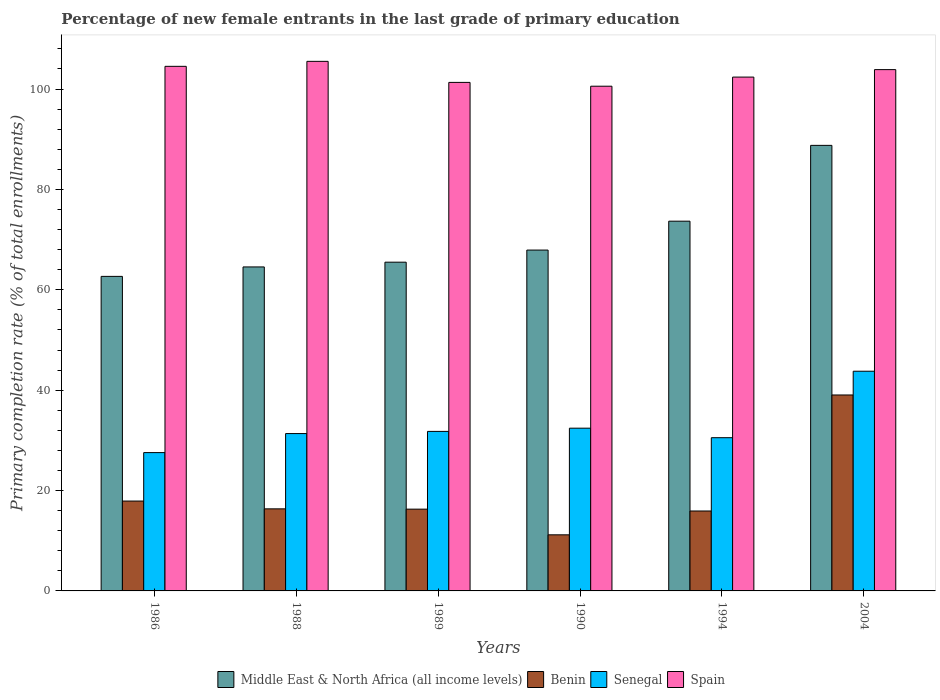How many bars are there on the 1st tick from the left?
Your answer should be compact. 4. How many bars are there on the 2nd tick from the right?
Offer a very short reply. 4. In how many cases, is the number of bars for a given year not equal to the number of legend labels?
Make the answer very short. 0. What is the percentage of new female entrants in Senegal in 1988?
Ensure brevity in your answer.  31.35. Across all years, what is the maximum percentage of new female entrants in Spain?
Offer a terse response. 105.51. Across all years, what is the minimum percentage of new female entrants in Senegal?
Offer a very short reply. 27.56. In which year was the percentage of new female entrants in Spain maximum?
Your answer should be compact. 1988. What is the total percentage of new female entrants in Benin in the graph?
Your response must be concise. 116.7. What is the difference between the percentage of new female entrants in Benin in 1986 and that in 1990?
Your response must be concise. 6.73. What is the difference between the percentage of new female entrants in Senegal in 1989 and the percentage of new female entrants in Spain in 1990?
Keep it short and to the point. -68.78. What is the average percentage of new female entrants in Benin per year?
Ensure brevity in your answer.  19.45. In the year 1986, what is the difference between the percentage of new female entrants in Senegal and percentage of new female entrants in Middle East & North Africa (all income levels)?
Provide a succinct answer. -35.11. In how many years, is the percentage of new female entrants in Spain greater than 12 %?
Offer a very short reply. 6. What is the ratio of the percentage of new female entrants in Spain in 1986 to that in 1994?
Ensure brevity in your answer.  1.02. Is the percentage of new female entrants in Middle East & North Africa (all income levels) in 1989 less than that in 1990?
Your answer should be compact. Yes. What is the difference between the highest and the second highest percentage of new female entrants in Senegal?
Make the answer very short. 11.35. What is the difference between the highest and the lowest percentage of new female entrants in Middle East & North Africa (all income levels)?
Give a very brief answer. 26.1. In how many years, is the percentage of new female entrants in Benin greater than the average percentage of new female entrants in Benin taken over all years?
Make the answer very short. 1. What does the 3rd bar from the left in 1988 represents?
Give a very brief answer. Senegal. What does the 3rd bar from the right in 1989 represents?
Ensure brevity in your answer.  Benin. Is it the case that in every year, the sum of the percentage of new female entrants in Benin and percentage of new female entrants in Spain is greater than the percentage of new female entrants in Senegal?
Your response must be concise. Yes. Are all the bars in the graph horizontal?
Ensure brevity in your answer.  No. What is the difference between two consecutive major ticks on the Y-axis?
Offer a terse response. 20. Does the graph contain grids?
Your answer should be compact. No. Where does the legend appear in the graph?
Your answer should be compact. Bottom center. What is the title of the graph?
Offer a terse response. Percentage of new female entrants in the last grade of primary education. Does "Tajikistan" appear as one of the legend labels in the graph?
Offer a terse response. No. What is the label or title of the X-axis?
Your answer should be very brief. Years. What is the label or title of the Y-axis?
Provide a short and direct response. Primary completion rate (% of total enrollments). What is the Primary completion rate (% of total enrollments) of Middle East & North Africa (all income levels) in 1986?
Your answer should be very brief. 62.67. What is the Primary completion rate (% of total enrollments) in Benin in 1986?
Your response must be concise. 17.91. What is the Primary completion rate (% of total enrollments) in Senegal in 1986?
Provide a short and direct response. 27.56. What is the Primary completion rate (% of total enrollments) of Spain in 1986?
Provide a short and direct response. 104.52. What is the Primary completion rate (% of total enrollments) of Middle East & North Africa (all income levels) in 1988?
Give a very brief answer. 64.55. What is the Primary completion rate (% of total enrollments) of Benin in 1988?
Provide a succinct answer. 16.35. What is the Primary completion rate (% of total enrollments) of Senegal in 1988?
Offer a terse response. 31.35. What is the Primary completion rate (% of total enrollments) in Spain in 1988?
Your answer should be compact. 105.51. What is the Primary completion rate (% of total enrollments) in Middle East & North Africa (all income levels) in 1989?
Ensure brevity in your answer.  65.5. What is the Primary completion rate (% of total enrollments) of Benin in 1989?
Provide a short and direct response. 16.29. What is the Primary completion rate (% of total enrollments) of Senegal in 1989?
Offer a terse response. 31.78. What is the Primary completion rate (% of total enrollments) of Spain in 1989?
Make the answer very short. 101.32. What is the Primary completion rate (% of total enrollments) of Middle East & North Africa (all income levels) in 1990?
Give a very brief answer. 67.91. What is the Primary completion rate (% of total enrollments) of Benin in 1990?
Offer a very short reply. 11.18. What is the Primary completion rate (% of total enrollments) of Senegal in 1990?
Offer a terse response. 32.43. What is the Primary completion rate (% of total enrollments) in Spain in 1990?
Ensure brevity in your answer.  100.56. What is the Primary completion rate (% of total enrollments) in Middle East & North Africa (all income levels) in 1994?
Ensure brevity in your answer.  73.67. What is the Primary completion rate (% of total enrollments) in Benin in 1994?
Make the answer very short. 15.92. What is the Primary completion rate (% of total enrollments) of Senegal in 1994?
Ensure brevity in your answer.  30.53. What is the Primary completion rate (% of total enrollments) of Spain in 1994?
Your response must be concise. 102.38. What is the Primary completion rate (% of total enrollments) of Middle East & North Africa (all income levels) in 2004?
Make the answer very short. 88.78. What is the Primary completion rate (% of total enrollments) of Benin in 2004?
Provide a succinct answer. 39.04. What is the Primary completion rate (% of total enrollments) in Senegal in 2004?
Your answer should be very brief. 43.77. What is the Primary completion rate (% of total enrollments) in Spain in 2004?
Provide a short and direct response. 103.87. Across all years, what is the maximum Primary completion rate (% of total enrollments) in Middle East & North Africa (all income levels)?
Ensure brevity in your answer.  88.78. Across all years, what is the maximum Primary completion rate (% of total enrollments) in Benin?
Offer a very short reply. 39.04. Across all years, what is the maximum Primary completion rate (% of total enrollments) in Senegal?
Make the answer very short. 43.77. Across all years, what is the maximum Primary completion rate (% of total enrollments) in Spain?
Your answer should be compact. 105.51. Across all years, what is the minimum Primary completion rate (% of total enrollments) of Middle East & North Africa (all income levels)?
Provide a succinct answer. 62.67. Across all years, what is the minimum Primary completion rate (% of total enrollments) in Benin?
Provide a short and direct response. 11.18. Across all years, what is the minimum Primary completion rate (% of total enrollments) of Senegal?
Provide a short and direct response. 27.56. Across all years, what is the minimum Primary completion rate (% of total enrollments) of Spain?
Your response must be concise. 100.56. What is the total Primary completion rate (% of total enrollments) of Middle East & North Africa (all income levels) in the graph?
Offer a very short reply. 423.08. What is the total Primary completion rate (% of total enrollments) of Benin in the graph?
Offer a terse response. 116.7. What is the total Primary completion rate (% of total enrollments) in Senegal in the graph?
Offer a very short reply. 197.42. What is the total Primary completion rate (% of total enrollments) of Spain in the graph?
Offer a very short reply. 618.16. What is the difference between the Primary completion rate (% of total enrollments) in Middle East & North Africa (all income levels) in 1986 and that in 1988?
Ensure brevity in your answer.  -1.88. What is the difference between the Primary completion rate (% of total enrollments) of Benin in 1986 and that in 1988?
Ensure brevity in your answer.  1.55. What is the difference between the Primary completion rate (% of total enrollments) in Senegal in 1986 and that in 1988?
Your response must be concise. -3.79. What is the difference between the Primary completion rate (% of total enrollments) in Spain in 1986 and that in 1988?
Your response must be concise. -0.99. What is the difference between the Primary completion rate (% of total enrollments) of Middle East & North Africa (all income levels) in 1986 and that in 1989?
Provide a short and direct response. -2.83. What is the difference between the Primary completion rate (% of total enrollments) of Benin in 1986 and that in 1989?
Your answer should be compact. 1.61. What is the difference between the Primary completion rate (% of total enrollments) of Senegal in 1986 and that in 1989?
Make the answer very short. -4.22. What is the difference between the Primary completion rate (% of total enrollments) of Spain in 1986 and that in 1989?
Provide a succinct answer. 3.2. What is the difference between the Primary completion rate (% of total enrollments) in Middle East & North Africa (all income levels) in 1986 and that in 1990?
Give a very brief answer. -5.24. What is the difference between the Primary completion rate (% of total enrollments) of Benin in 1986 and that in 1990?
Provide a succinct answer. 6.73. What is the difference between the Primary completion rate (% of total enrollments) in Senegal in 1986 and that in 1990?
Your answer should be compact. -4.87. What is the difference between the Primary completion rate (% of total enrollments) in Spain in 1986 and that in 1990?
Your response must be concise. 3.96. What is the difference between the Primary completion rate (% of total enrollments) of Middle East & North Africa (all income levels) in 1986 and that in 1994?
Provide a short and direct response. -11. What is the difference between the Primary completion rate (% of total enrollments) of Benin in 1986 and that in 1994?
Your answer should be very brief. 1.98. What is the difference between the Primary completion rate (% of total enrollments) in Senegal in 1986 and that in 1994?
Ensure brevity in your answer.  -2.97. What is the difference between the Primary completion rate (% of total enrollments) in Spain in 1986 and that in 1994?
Your answer should be compact. 2.14. What is the difference between the Primary completion rate (% of total enrollments) of Middle East & North Africa (all income levels) in 1986 and that in 2004?
Keep it short and to the point. -26.1. What is the difference between the Primary completion rate (% of total enrollments) in Benin in 1986 and that in 2004?
Your response must be concise. -21.14. What is the difference between the Primary completion rate (% of total enrollments) in Senegal in 1986 and that in 2004?
Your answer should be very brief. -16.21. What is the difference between the Primary completion rate (% of total enrollments) of Spain in 1986 and that in 2004?
Offer a very short reply. 0.65. What is the difference between the Primary completion rate (% of total enrollments) of Middle East & North Africa (all income levels) in 1988 and that in 1989?
Provide a short and direct response. -0.95. What is the difference between the Primary completion rate (% of total enrollments) in Benin in 1988 and that in 1989?
Your response must be concise. 0.06. What is the difference between the Primary completion rate (% of total enrollments) of Senegal in 1988 and that in 1989?
Provide a succinct answer. -0.43. What is the difference between the Primary completion rate (% of total enrollments) of Spain in 1988 and that in 1989?
Provide a succinct answer. 4.19. What is the difference between the Primary completion rate (% of total enrollments) of Middle East & North Africa (all income levels) in 1988 and that in 1990?
Provide a succinct answer. -3.36. What is the difference between the Primary completion rate (% of total enrollments) in Benin in 1988 and that in 1990?
Offer a terse response. 5.18. What is the difference between the Primary completion rate (% of total enrollments) in Senegal in 1988 and that in 1990?
Make the answer very short. -1.08. What is the difference between the Primary completion rate (% of total enrollments) in Spain in 1988 and that in 1990?
Make the answer very short. 4.95. What is the difference between the Primary completion rate (% of total enrollments) in Middle East & North Africa (all income levels) in 1988 and that in 1994?
Offer a terse response. -9.12. What is the difference between the Primary completion rate (% of total enrollments) in Benin in 1988 and that in 1994?
Offer a very short reply. 0.43. What is the difference between the Primary completion rate (% of total enrollments) in Senegal in 1988 and that in 1994?
Offer a terse response. 0.82. What is the difference between the Primary completion rate (% of total enrollments) in Spain in 1988 and that in 1994?
Ensure brevity in your answer.  3.14. What is the difference between the Primary completion rate (% of total enrollments) in Middle East & North Africa (all income levels) in 1988 and that in 2004?
Your response must be concise. -24.22. What is the difference between the Primary completion rate (% of total enrollments) of Benin in 1988 and that in 2004?
Offer a terse response. -22.69. What is the difference between the Primary completion rate (% of total enrollments) in Senegal in 1988 and that in 2004?
Ensure brevity in your answer.  -12.42. What is the difference between the Primary completion rate (% of total enrollments) in Spain in 1988 and that in 2004?
Your answer should be compact. 1.65. What is the difference between the Primary completion rate (% of total enrollments) in Middle East & North Africa (all income levels) in 1989 and that in 1990?
Keep it short and to the point. -2.41. What is the difference between the Primary completion rate (% of total enrollments) of Benin in 1989 and that in 1990?
Ensure brevity in your answer.  5.12. What is the difference between the Primary completion rate (% of total enrollments) in Senegal in 1989 and that in 1990?
Offer a terse response. -0.64. What is the difference between the Primary completion rate (% of total enrollments) in Spain in 1989 and that in 1990?
Make the answer very short. 0.76. What is the difference between the Primary completion rate (% of total enrollments) in Middle East & North Africa (all income levels) in 1989 and that in 1994?
Give a very brief answer. -8.17. What is the difference between the Primary completion rate (% of total enrollments) in Benin in 1989 and that in 1994?
Make the answer very short. 0.37. What is the difference between the Primary completion rate (% of total enrollments) in Senegal in 1989 and that in 1994?
Ensure brevity in your answer.  1.25. What is the difference between the Primary completion rate (% of total enrollments) of Spain in 1989 and that in 1994?
Provide a succinct answer. -1.06. What is the difference between the Primary completion rate (% of total enrollments) of Middle East & North Africa (all income levels) in 1989 and that in 2004?
Provide a succinct answer. -23.27. What is the difference between the Primary completion rate (% of total enrollments) of Benin in 1989 and that in 2004?
Ensure brevity in your answer.  -22.75. What is the difference between the Primary completion rate (% of total enrollments) in Senegal in 1989 and that in 2004?
Offer a very short reply. -11.99. What is the difference between the Primary completion rate (% of total enrollments) in Spain in 1989 and that in 2004?
Your answer should be compact. -2.55. What is the difference between the Primary completion rate (% of total enrollments) in Middle East & North Africa (all income levels) in 1990 and that in 1994?
Provide a succinct answer. -5.75. What is the difference between the Primary completion rate (% of total enrollments) in Benin in 1990 and that in 1994?
Your response must be concise. -4.75. What is the difference between the Primary completion rate (% of total enrollments) in Senegal in 1990 and that in 1994?
Your answer should be compact. 1.9. What is the difference between the Primary completion rate (% of total enrollments) in Spain in 1990 and that in 1994?
Provide a short and direct response. -1.82. What is the difference between the Primary completion rate (% of total enrollments) in Middle East & North Africa (all income levels) in 1990 and that in 2004?
Provide a succinct answer. -20.86. What is the difference between the Primary completion rate (% of total enrollments) in Benin in 1990 and that in 2004?
Offer a terse response. -27.87. What is the difference between the Primary completion rate (% of total enrollments) of Senegal in 1990 and that in 2004?
Give a very brief answer. -11.35. What is the difference between the Primary completion rate (% of total enrollments) in Spain in 1990 and that in 2004?
Provide a short and direct response. -3.31. What is the difference between the Primary completion rate (% of total enrollments) of Middle East & North Africa (all income levels) in 1994 and that in 2004?
Offer a very short reply. -15.11. What is the difference between the Primary completion rate (% of total enrollments) of Benin in 1994 and that in 2004?
Provide a short and direct response. -23.12. What is the difference between the Primary completion rate (% of total enrollments) in Senegal in 1994 and that in 2004?
Your answer should be compact. -13.24. What is the difference between the Primary completion rate (% of total enrollments) in Spain in 1994 and that in 2004?
Keep it short and to the point. -1.49. What is the difference between the Primary completion rate (% of total enrollments) of Middle East & North Africa (all income levels) in 1986 and the Primary completion rate (% of total enrollments) of Benin in 1988?
Offer a very short reply. 46.32. What is the difference between the Primary completion rate (% of total enrollments) of Middle East & North Africa (all income levels) in 1986 and the Primary completion rate (% of total enrollments) of Senegal in 1988?
Give a very brief answer. 31.32. What is the difference between the Primary completion rate (% of total enrollments) of Middle East & North Africa (all income levels) in 1986 and the Primary completion rate (% of total enrollments) of Spain in 1988?
Give a very brief answer. -42.84. What is the difference between the Primary completion rate (% of total enrollments) of Benin in 1986 and the Primary completion rate (% of total enrollments) of Senegal in 1988?
Offer a terse response. -13.44. What is the difference between the Primary completion rate (% of total enrollments) in Benin in 1986 and the Primary completion rate (% of total enrollments) in Spain in 1988?
Keep it short and to the point. -87.61. What is the difference between the Primary completion rate (% of total enrollments) in Senegal in 1986 and the Primary completion rate (% of total enrollments) in Spain in 1988?
Make the answer very short. -77.95. What is the difference between the Primary completion rate (% of total enrollments) in Middle East & North Africa (all income levels) in 1986 and the Primary completion rate (% of total enrollments) in Benin in 1989?
Offer a terse response. 46.38. What is the difference between the Primary completion rate (% of total enrollments) in Middle East & North Africa (all income levels) in 1986 and the Primary completion rate (% of total enrollments) in Senegal in 1989?
Your response must be concise. 30.89. What is the difference between the Primary completion rate (% of total enrollments) in Middle East & North Africa (all income levels) in 1986 and the Primary completion rate (% of total enrollments) in Spain in 1989?
Make the answer very short. -38.65. What is the difference between the Primary completion rate (% of total enrollments) in Benin in 1986 and the Primary completion rate (% of total enrollments) in Senegal in 1989?
Offer a very short reply. -13.88. What is the difference between the Primary completion rate (% of total enrollments) in Benin in 1986 and the Primary completion rate (% of total enrollments) in Spain in 1989?
Keep it short and to the point. -83.41. What is the difference between the Primary completion rate (% of total enrollments) in Senegal in 1986 and the Primary completion rate (% of total enrollments) in Spain in 1989?
Give a very brief answer. -73.76. What is the difference between the Primary completion rate (% of total enrollments) in Middle East & North Africa (all income levels) in 1986 and the Primary completion rate (% of total enrollments) in Benin in 1990?
Your response must be concise. 51.49. What is the difference between the Primary completion rate (% of total enrollments) of Middle East & North Africa (all income levels) in 1986 and the Primary completion rate (% of total enrollments) of Senegal in 1990?
Give a very brief answer. 30.24. What is the difference between the Primary completion rate (% of total enrollments) of Middle East & North Africa (all income levels) in 1986 and the Primary completion rate (% of total enrollments) of Spain in 1990?
Offer a very short reply. -37.89. What is the difference between the Primary completion rate (% of total enrollments) in Benin in 1986 and the Primary completion rate (% of total enrollments) in Senegal in 1990?
Offer a very short reply. -14.52. What is the difference between the Primary completion rate (% of total enrollments) of Benin in 1986 and the Primary completion rate (% of total enrollments) of Spain in 1990?
Provide a short and direct response. -82.66. What is the difference between the Primary completion rate (% of total enrollments) in Senegal in 1986 and the Primary completion rate (% of total enrollments) in Spain in 1990?
Keep it short and to the point. -73. What is the difference between the Primary completion rate (% of total enrollments) of Middle East & North Africa (all income levels) in 1986 and the Primary completion rate (% of total enrollments) of Benin in 1994?
Provide a short and direct response. 46.75. What is the difference between the Primary completion rate (% of total enrollments) in Middle East & North Africa (all income levels) in 1986 and the Primary completion rate (% of total enrollments) in Senegal in 1994?
Ensure brevity in your answer.  32.14. What is the difference between the Primary completion rate (% of total enrollments) in Middle East & North Africa (all income levels) in 1986 and the Primary completion rate (% of total enrollments) in Spain in 1994?
Offer a very short reply. -39.71. What is the difference between the Primary completion rate (% of total enrollments) of Benin in 1986 and the Primary completion rate (% of total enrollments) of Senegal in 1994?
Offer a very short reply. -12.62. What is the difference between the Primary completion rate (% of total enrollments) in Benin in 1986 and the Primary completion rate (% of total enrollments) in Spain in 1994?
Your response must be concise. -84.47. What is the difference between the Primary completion rate (% of total enrollments) in Senegal in 1986 and the Primary completion rate (% of total enrollments) in Spain in 1994?
Your response must be concise. -74.82. What is the difference between the Primary completion rate (% of total enrollments) of Middle East & North Africa (all income levels) in 1986 and the Primary completion rate (% of total enrollments) of Benin in 2004?
Give a very brief answer. 23.63. What is the difference between the Primary completion rate (% of total enrollments) in Middle East & North Africa (all income levels) in 1986 and the Primary completion rate (% of total enrollments) in Senegal in 2004?
Your answer should be very brief. 18.9. What is the difference between the Primary completion rate (% of total enrollments) of Middle East & North Africa (all income levels) in 1986 and the Primary completion rate (% of total enrollments) of Spain in 2004?
Your answer should be compact. -41.2. What is the difference between the Primary completion rate (% of total enrollments) in Benin in 1986 and the Primary completion rate (% of total enrollments) in Senegal in 2004?
Your answer should be compact. -25.87. What is the difference between the Primary completion rate (% of total enrollments) in Benin in 1986 and the Primary completion rate (% of total enrollments) in Spain in 2004?
Provide a short and direct response. -85.96. What is the difference between the Primary completion rate (% of total enrollments) in Senegal in 1986 and the Primary completion rate (% of total enrollments) in Spain in 2004?
Ensure brevity in your answer.  -76.31. What is the difference between the Primary completion rate (% of total enrollments) in Middle East & North Africa (all income levels) in 1988 and the Primary completion rate (% of total enrollments) in Benin in 1989?
Give a very brief answer. 48.26. What is the difference between the Primary completion rate (% of total enrollments) in Middle East & North Africa (all income levels) in 1988 and the Primary completion rate (% of total enrollments) in Senegal in 1989?
Your response must be concise. 32.77. What is the difference between the Primary completion rate (% of total enrollments) of Middle East & North Africa (all income levels) in 1988 and the Primary completion rate (% of total enrollments) of Spain in 1989?
Give a very brief answer. -36.77. What is the difference between the Primary completion rate (% of total enrollments) in Benin in 1988 and the Primary completion rate (% of total enrollments) in Senegal in 1989?
Provide a short and direct response. -15.43. What is the difference between the Primary completion rate (% of total enrollments) in Benin in 1988 and the Primary completion rate (% of total enrollments) in Spain in 1989?
Offer a terse response. -84.97. What is the difference between the Primary completion rate (% of total enrollments) in Senegal in 1988 and the Primary completion rate (% of total enrollments) in Spain in 1989?
Make the answer very short. -69.97. What is the difference between the Primary completion rate (% of total enrollments) of Middle East & North Africa (all income levels) in 1988 and the Primary completion rate (% of total enrollments) of Benin in 1990?
Make the answer very short. 53.38. What is the difference between the Primary completion rate (% of total enrollments) of Middle East & North Africa (all income levels) in 1988 and the Primary completion rate (% of total enrollments) of Senegal in 1990?
Ensure brevity in your answer.  32.13. What is the difference between the Primary completion rate (% of total enrollments) of Middle East & North Africa (all income levels) in 1988 and the Primary completion rate (% of total enrollments) of Spain in 1990?
Keep it short and to the point. -36.01. What is the difference between the Primary completion rate (% of total enrollments) in Benin in 1988 and the Primary completion rate (% of total enrollments) in Senegal in 1990?
Your response must be concise. -16.07. What is the difference between the Primary completion rate (% of total enrollments) of Benin in 1988 and the Primary completion rate (% of total enrollments) of Spain in 1990?
Offer a terse response. -84.21. What is the difference between the Primary completion rate (% of total enrollments) of Senegal in 1988 and the Primary completion rate (% of total enrollments) of Spain in 1990?
Your answer should be very brief. -69.21. What is the difference between the Primary completion rate (% of total enrollments) of Middle East & North Africa (all income levels) in 1988 and the Primary completion rate (% of total enrollments) of Benin in 1994?
Provide a short and direct response. 48.63. What is the difference between the Primary completion rate (% of total enrollments) of Middle East & North Africa (all income levels) in 1988 and the Primary completion rate (% of total enrollments) of Senegal in 1994?
Offer a terse response. 34.02. What is the difference between the Primary completion rate (% of total enrollments) in Middle East & North Africa (all income levels) in 1988 and the Primary completion rate (% of total enrollments) in Spain in 1994?
Keep it short and to the point. -37.83. What is the difference between the Primary completion rate (% of total enrollments) in Benin in 1988 and the Primary completion rate (% of total enrollments) in Senegal in 1994?
Keep it short and to the point. -14.18. What is the difference between the Primary completion rate (% of total enrollments) of Benin in 1988 and the Primary completion rate (% of total enrollments) of Spain in 1994?
Make the answer very short. -86.02. What is the difference between the Primary completion rate (% of total enrollments) in Senegal in 1988 and the Primary completion rate (% of total enrollments) in Spain in 1994?
Your answer should be very brief. -71.03. What is the difference between the Primary completion rate (% of total enrollments) of Middle East & North Africa (all income levels) in 1988 and the Primary completion rate (% of total enrollments) of Benin in 2004?
Your answer should be very brief. 25.51. What is the difference between the Primary completion rate (% of total enrollments) of Middle East & North Africa (all income levels) in 1988 and the Primary completion rate (% of total enrollments) of Senegal in 2004?
Offer a very short reply. 20.78. What is the difference between the Primary completion rate (% of total enrollments) in Middle East & North Africa (all income levels) in 1988 and the Primary completion rate (% of total enrollments) in Spain in 2004?
Your response must be concise. -39.32. What is the difference between the Primary completion rate (% of total enrollments) in Benin in 1988 and the Primary completion rate (% of total enrollments) in Senegal in 2004?
Ensure brevity in your answer.  -27.42. What is the difference between the Primary completion rate (% of total enrollments) of Benin in 1988 and the Primary completion rate (% of total enrollments) of Spain in 2004?
Your answer should be very brief. -87.51. What is the difference between the Primary completion rate (% of total enrollments) in Senegal in 1988 and the Primary completion rate (% of total enrollments) in Spain in 2004?
Ensure brevity in your answer.  -72.52. What is the difference between the Primary completion rate (% of total enrollments) in Middle East & North Africa (all income levels) in 1989 and the Primary completion rate (% of total enrollments) in Benin in 1990?
Make the answer very short. 54.32. What is the difference between the Primary completion rate (% of total enrollments) of Middle East & North Africa (all income levels) in 1989 and the Primary completion rate (% of total enrollments) of Senegal in 1990?
Your answer should be compact. 33.07. What is the difference between the Primary completion rate (% of total enrollments) of Middle East & North Africa (all income levels) in 1989 and the Primary completion rate (% of total enrollments) of Spain in 1990?
Provide a short and direct response. -35.06. What is the difference between the Primary completion rate (% of total enrollments) in Benin in 1989 and the Primary completion rate (% of total enrollments) in Senegal in 1990?
Provide a short and direct response. -16.13. What is the difference between the Primary completion rate (% of total enrollments) in Benin in 1989 and the Primary completion rate (% of total enrollments) in Spain in 1990?
Provide a succinct answer. -84.27. What is the difference between the Primary completion rate (% of total enrollments) of Senegal in 1989 and the Primary completion rate (% of total enrollments) of Spain in 1990?
Provide a succinct answer. -68.78. What is the difference between the Primary completion rate (% of total enrollments) of Middle East & North Africa (all income levels) in 1989 and the Primary completion rate (% of total enrollments) of Benin in 1994?
Your response must be concise. 49.58. What is the difference between the Primary completion rate (% of total enrollments) of Middle East & North Africa (all income levels) in 1989 and the Primary completion rate (% of total enrollments) of Senegal in 1994?
Ensure brevity in your answer.  34.97. What is the difference between the Primary completion rate (% of total enrollments) of Middle East & North Africa (all income levels) in 1989 and the Primary completion rate (% of total enrollments) of Spain in 1994?
Your response must be concise. -36.88. What is the difference between the Primary completion rate (% of total enrollments) of Benin in 1989 and the Primary completion rate (% of total enrollments) of Senegal in 1994?
Provide a succinct answer. -14.24. What is the difference between the Primary completion rate (% of total enrollments) in Benin in 1989 and the Primary completion rate (% of total enrollments) in Spain in 1994?
Provide a short and direct response. -86.08. What is the difference between the Primary completion rate (% of total enrollments) in Senegal in 1989 and the Primary completion rate (% of total enrollments) in Spain in 1994?
Your response must be concise. -70.59. What is the difference between the Primary completion rate (% of total enrollments) of Middle East & North Africa (all income levels) in 1989 and the Primary completion rate (% of total enrollments) of Benin in 2004?
Your answer should be very brief. 26.46. What is the difference between the Primary completion rate (% of total enrollments) of Middle East & North Africa (all income levels) in 1989 and the Primary completion rate (% of total enrollments) of Senegal in 2004?
Your answer should be compact. 21.73. What is the difference between the Primary completion rate (% of total enrollments) of Middle East & North Africa (all income levels) in 1989 and the Primary completion rate (% of total enrollments) of Spain in 2004?
Offer a very short reply. -38.37. What is the difference between the Primary completion rate (% of total enrollments) in Benin in 1989 and the Primary completion rate (% of total enrollments) in Senegal in 2004?
Give a very brief answer. -27.48. What is the difference between the Primary completion rate (% of total enrollments) of Benin in 1989 and the Primary completion rate (% of total enrollments) of Spain in 2004?
Offer a terse response. -87.57. What is the difference between the Primary completion rate (% of total enrollments) of Senegal in 1989 and the Primary completion rate (% of total enrollments) of Spain in 2004?
Offer a very short reply. -72.08. What is the difference between the Primary completion rate (% of total enrollments) of Middle East & North Africa (all income levels) in 1990 and the Primary completion rate (% of total enrollments) of Benin in 1994?
Give a very brief answer. 51.99. What is the difference between the Primary completion rate (% of total enrollments) in Middle East & North Africa (all income levels) in 1990 and the Primary completion rate (% of total enrollments) in Senegal in 1994?
Your response must be concise. 37.38. What is the difference between the Primary completion rate (% of total enrollments) of Middle East & North Africa (all income levels) in 1990 and the Primary completion rate (% of total enrollments) of Spain in 1994?
Provide a succinct answer. -34.46. What is the difference between the Primary completion rate (% of total enrollments) in Benin in 1990 and the Primary completion rate (% of total enrollments) in Senegal in 1994?
Your response must be concise. -19.35. What is the difference between the Primary completion rate (% of total enrollments) of Benin in 1990 and the Primary completion rate (% of total enrollments) of Spain in 1994?
Offer a terse response. -91.2. What is the difference between the Primary completion rate (% of total enrollments) of Senegal in 1990 and the Primary completion rate (% of total enrollments) of Spain in 1994?
Ensure brevity in your answer.  -69.95. What is the difference between the Primary completion rate (% of total enrollments) in Middle East & North Africa (all income levels) in 1990 and the Primary completion rate (% of total enrollments) in Benin in 2004?
Provide a short and direct response. 28.87. What is the difference between the Primary completion rate (% of total enrollments) in Middle East & North Africa (all income levels) in 1990 and the Primary completion rate (% of total enrollments) in Senegal in 2004?
Give a very brief answer. 24.14. What is the difference between the Primary completion rate (% of total enrollments) of Middle East & North Africa (all income levels) in 1990 and the Primary completion rate (% of total enrollments) of Spain in 2004?
Make the answer very short. -35.95. What is the difference between the Primary completion rate (% of total enrollments) in Benin in 1990 and the Primary completion rate (% of total enrollments) in Senegal in 2004?
Your answer should be compact. -32.6. What is the difference between the Primary completion rate (% of total enrollments) of Benin in 1990 and the Primary completion rate (% of total enrollments) of Spain in 2004?
Your answer should be compact. -92.69. What is the difference between the Primary completion rate (% of total enrollments) of Senegal in 1990 and the Primary completion rate (% of total enrollments) of Spain in 2004?
Ensure brevity in your answer.  -71.44. What is the difference between the Primary completion rate (% of total enrollments) in Middle East & North Africa (all income levels) in 1994 and the Primary completion rate (% of total enrollments) in Benin in 2004?
Offer a very short reply. 34.62. What is the difference between the Primary completion rate (% of total enrollments) in Middle East & North Africa (all income levels) in 1994 and the Primary completion rate (% of total enrollments) in Senegal in 2004?
Keep it short and to the point. 29.9. What is the difference between the Primary completion rate (% of total enrollments) of Middle East & North Africa (all income levels) in 1994 and the Primary completion rate (% of total enrollments) of Spain in 2004?
Your answer should be compact. -30.2. What is the difference between the Primary completion rate (% of total enrollments) of Benin in 1994 and the Primary completion rate (% of total enrollments) of Senegal in 2004?
Provide a succinct answer. -27.85. What is the difference between the Primary completion rate (% of total enrollments) in Benin in 1994 and the Primary completion rate (% of total enrollments) in Spain in 2004?
Offer a terse response. -87.94. What is the difference between the Primary completion rate (% of total enrollments) of Senegal in 1994 and the Primary completion rate (% of total enrollments) of Spain in 2004?
Ensure brevity in your answer.  -73.34. What is the average Primary completion rate (% of total enrollments) in Middle East & North Africa (all income levels) per year?
Offer a very short reply. 70.51. What is the average Primary completion rate (% of total enrollments) of Benin per year?
Your answer should be very brief. 19.45. What is the average Primary completion rate (% of total enrollments) of Senegal per year?
Your answer should be compact. 32.9. What is the average Primary completion rate (% of total enrollments) of Spain per year?
Keep it short and to the point. 103.03. In the year 1986, what is the difference between the Primary completion rate (% of total enrollments) of Middle East & North Africa (all income levels) and Primary completion rate (% of total enrollments) of Benin?
Offer a terse response. 44.76. In the year 1986, what is the difference between the Primary completion rate (% of total enrollments) of Middle East & North Africa (all income levels) and Primary completion rate (% of total enrollments) of Senegal?
Offer a very short reply. 35.11. In the year 1986, what is the difference between the Primary completion rate (% of total enrollments) in Middle East & North Africa (all income levels) and Primary completion rate (% of total enrollments) in Spain?
Give a very brief answer. -41.85. In the year 1986, what is the difference between the Primary completion rate (% of total enrollments) in Benin and Primary completion rate (% of total enrollments) in Senegal?
Give a very brief answer. -9.65. In the year 1986, what is the difference between the Primary completion rate (% of total enrollments) of Benin and Primary completion rate (% of total enrollments) of Spain?
Keep it short and to the point. -86.62. In the year 1986, what is the difference between the Primary completion rate (% of total enrollments) of Senegal and Primary completion rate (% of total enrollments) of Spain?
Keep it short and to the point. -76.96. In the year 1988, what is the difference between the Primary completion rate (% of total enrollments) of Middle East & North Africa (all income levels) and Primary completion rate (% of total enrollments) of Benin?
Offer a very short reply. 48.2. In the year 1988, what is the difference between the Primary completion rate (% of total enrollments) in Middle East & North Africa (all income levels) and Primary completion rate (% of total enrollments) in Senegal?
Provide a succinct answer. 33.2. In the year 1988, what is the difference between the Primary completion rate (% of total enrollments) of Middle East & North Africa (all income levels) and Primary completion rate (% of total enrollments) of Spain?
Your answer should be compact. -40.96. In the year 1988, what is the difference between the Primary completion rate (% of total enrollments) of Benin and Primary completion rate (% of total enrollments) of Senegal?
Keep it short and to the point. -15. In the year 1988, what is the difference between the Primary completion rate (% of total enrollments) in Benin and Primary completion rate (% of total enrollments) in Spain?
Offer a very short reply. -89.16. In the year 1988, what is the difference between the Primary completion rate (% of total enrollments) in Senegal and Primary completion rate (% of total enrollments) in Spain?
Keep it short and to the point. -74.16. In the year 1989, what is the difference between the Primary completion rate (% of total enrollments) of Middle East & North Africa (all income levels) and Primary completion rate (% of total enrollments) of Benin?
Your response must be concise. 49.21. In the year 1989, what is the difference between the Primary completion rate (% of total enrollments) of Middle East & North Africa (all income levels) and Primary completion rate (% of total enrollments) of Senegal?
Provide a short and direct response. 33.72. In the year 1989, what is the difference between the Primary completion rate (% of total enrollments) of Middle East & North Africa (all income levels) and Primary completion rate (% of total enrollments) of Spain?
Offer a very short reply. -35.82. In the year 1989, what is the difference between the Primary completion rate (% of total enrollments) in Benin and Primary completion rate (% of total enrollments) in Senegal?
Provide a short and direct response. -15.49. In the year 1989, what is the difference between the Primary completion rate (% of total enrollments) of Benin and Primary completion rate (% of total enrollments) of Spain?
Offer a terse response. -85.02. In the year 1989, what is the difference between the Primary completion rate (% of total enrollments) in Senegal and Primary completion rate (% of total enrollments) in Spain?
Provide a short and direct response. -69.54. In the year 1990, what is the difference between the Primary completion rate (% of total enrollments) of Middle East & North Africa (all income levels) and Primary completion rate (% of total enrollments) of Benin?
Give a very brief answer. 56.74. In the year 1990, what is the difference between the Primary completion rate (% of total enrollments) of Middle East & North Africa (all income levels) and Primary completion rate (% of total enrollments) of Senegal?
Give a very brief answer. 35.49. In the year 1990, what is the difference between the Primary completion rate (% of total enrollments) of Middle East & North Africa (all income levels) and Primary completion rate (% of total enrollments) of Spain?
Keep it short and to the point. -32.65. In the year 1990, what is the difference between the Primary completion rate (% of total enrollments) in Benin and Primary completion rate (% of total enrollments) in Senegal?
Your answer should be very brief. -21.25. In the year 1990, what is the difference between the Primary completion rate (% of total enrollments) of Benin and Primary completion rate (% of total enrollments) of Spain?
Provide a succinct answer. -89.38. In the year 1990, what is the difference between the Primary completion rate (% of total enrollments) in Senegal and Primary completion rate (% of total enrollments) in Spain?
Provide a short and direct response. -68.13. In the year 1994, what is the difference between the Primary completion rate (% of total enrollments) in Middle East & North Africa (all income levels) and Primary completion rate (% of total enrollments) in Benin?
Make the answer very short. 57.74. In the year 1994, what is the difference between the Primary completion rate (% of total enrollments) in Middle East & North Africa (all income levels) and Primary completion rate (% of total enrollments) in Senegal?
Give a very brief answer. 43.14. In the year 1994, what is the difference between the Primary completion rate (% of total enrollments) in Middle East & North Africa (all income levels) and Primary completion rate (% of total enrollments) in Spain?
Give a very brief answer. -28.71. In the year 1994, what is the difference between the Primary completion rate (% of total enrollments) of Benin and Primary completion rate (% of total enrollments) of Senegal?
Provide a short and direct response. -14.61. In the year 1994, what is the difference between the Primary completion rate (% of total enrollments) in Benin and Primary completion rate (% of total enrollments) in Spain?
Ensure brevity in your answer.  -86.45. In the year 1994, what is the difference between the Primary completion rate (% of total enrollments) in Senegal and Primary completion rate (% of total enrollments) in Spain?
Give a very brief answer. -71.85. In the year 2004, what is the difference between the Primary completion rate (% of total enrollments) in Middle East & North Africa (all income levels) and Primary completion rate (% of total enrollments) in Benin?
Your answer should be very brief. 49.73. In the year 2004, what is the difference between the Primary completion rate (% of total enrollments) of Middle East & North Africa (all income levels) and Primary completion rate (% of total enrollments) of Senegal?
Keep it short and to the point. 45. In the year 2004, what is the difference between the Primary completion rate (% of total enrollments) in Middle East & North Africa (all income levels) and Primary completion rate (% of total enrollments) in Spain?
Your answer should be compact. -15.09. In the year 2004, what is the difference between the Primary completion rate (% of total enrollments) in Benin and Primary completion rate (% of total enrollments) in Senegal?
Offer a very short reply. -4.73. In the year 2004, what is the difference between the Primary completion rate (% of total enrollments) of Benin and Primary completion rate (% of total enrollments) of Spain?
Make the answer very short. -64.83. In the year 2004, what is the difference between the Primary completion rate (% of total enrollments) in Senegal and Primary completion rate (% of total enrollments) in Spain?
Your answer should be very brief. -60.1. What is the ratio of the Primary completion rate (% of total enrollments) in Middle East & North Africa (all income levels) in 1986 to that in 1988?
Your answer should be compact. 0.97. What is the ratio of the Primary completion rate (% of total enrollments) of Benin in 1986 to that in 1988?
Provide a succinct answer. 1.09. What is the ratio of the Primary completion rate (% of total enrollments) of Senegal in 1986 to that in 1988?
Offer a very short reply. 0.88. What is the ratio of the Primary completion rate (% of total enrollments) in Spain in 1986 to that in 1988?
Provide a succinct answer. 0.99. What is the ratio of the Primary completion rate (% of total enrollments) in Middle East & North Africa (all income levels) in 1986 to that in 1989?
Keep it short and to the point. 0.96. What is the ratio of the Primary completion rate (% of total enrollments) of Benin in 1986 to that in 1989?
Your answer should be compact. 1.1. What is the ratio of the Primary completion rate (% of total enrollments) in Senegal in 1986 to that in 1989?
Provide a short and direct response. 0.87. What is the ratio of the Primary completion rate (% of total enrollments) in Spain in 1986 to that in 1989?
Provide a succinct answer. 1.03. What is the ratio of the Primary completion rate (% of total enrollments) of Middle East & North Africa (all income levels) in 1986 to that in 1990?
Keep it short and to the point. 0.92. What is the ratio of the Primary completion rate (% of total enrollments) in Benin in 1986 to that in 1990?
Provide a succinct answer. 1.6. What is the ratio of the Primary completion rate (% of total enrollments) of Senegal in 1986 to that in 1990?
Give a very brief answer. 0.85. What is the ratio of the Primary completion rate (% of total enrollments) in Spain in 1986 to that in 1990?
Provide a succinct answer. 1.04. What is the ratio of the Primary completion rate (% of total enrollments) in Middle East & North Africa (all income levels) in 1986 to that in 1994?
Your answer should be very brief. 0.85. What is the ratio of the Primary completion rate (% of total enrollments) in Benin in 1986 to that in 1994?
Make the answer very short. 1.12. What is the ratio of the Primary completion rate (% of total enrollments) in Senegal in 1986 to that in 1994?
Your answer should be compact. 0.9. What is the ratio of the Primary completion rate (% of total enrollments) in Spain in 1986 to that in 1994?
Provide a succinct answer. 1.02. What is the ratio of the Primary completion rate (% of total enrollments) of Middle East & North Africa (all income levels) in 1986 to that in 2004?
Offer a terse response. 0.71. What is the ratio of the Primary completion rate (% of total enrollments) of Benin in 1986 to that in 2004?
Ensure brevity in your answer.  0.46. What is the ratio of the Primary completion rate (% of total enrollments) in Senegal in 1986 to that in 2004?
Your answer should be very brief. 0.63. What is the ratio of the Primary completion rate (% of total enrollments) of Spain in 1986 to that in 2004?
Offer a terse response. 1.01. What is the ratio of the Primary completion rate (% of total enrollments) in Middle East & North Africa (all income levels) in 1988 to that in 1989?
Your answer should be very brief. 0.99. What is the ratio of the Primary completion rate (% of total enrollments) of Senegal in 1988 to that in 1989?
Your answer should be very brief. 0.99. What is the ratio of the Primary completion rate (% of total enrollments) in Spain in 1988 to that in 1989?
Offer a terse response. 1.04. What is the ratio of the Primary completion rate (% of total enrollments) of Middle East & North Africa (all income levels) in 1988 to that in 1990?
Your answer should be very brief. 0.95. What is the ratio of the Primary completion rate (% of total enrollments) in Benin in 1988 to that in 1990?
Ensure brevity in your answer.  1.46. What is the ratio of the Primary completion rate (% of total enrollments) of Senegal in 1988 to that in 1990?
Give a very brief answer. 0.97. What is the ratio of the Primary completion rate (% of total enrollments) of Spain in 1988 to that in 1990?
Provide a succinct answer. 1.05. What is the ratio of the Primary completion rate (% of total enrollments) in Middle East & North Africa (all income levels) in 1988 to that in 1994?
Offer a very short reply. 0.88. What is the ratio of the Primary completion rate (% of total enrollments) in Benin in 1988 to that in 1994?
Provide a succinct answer. 1.03. What is the ratio of the Primary completion rate (% of total enrollments) of Senegal in 1988 to that in 1994?
Offer a very short reply. 1.03. What is the ratio of the Primary completion rate (% of total enrollments) of Spain in 1988 to that in 1994?
Provide a short and direct response. 1.03. What is the ratio of the Primary completion rate (% of total enrollments) of Middle East & North Africa (all income levels) in 1988 to that in 2004?
Provide a succinct answer. 0.73. What is the ratio of the Primary completion rate (% of total enrollments) in Benin in 1988 to that in 2004?
Give a very brief answer. 0.42. What is the ratio of the Primary completion rate (% of total enrollments) of Senegal in 1988 to that in 2004?
Ensure brevity in your answer.  0.72. What is the ratio of the Primary completion rate (% of total enrollments) of Spain in 1988 to that in 2004?
Offer a very short reply. 1.02. What is the ratio of the Primary completion rate (% of total enrollments) of Middle East & North Africa (all income levels) in 1989 to that in 1990?
Provide a succinct answer. 0.96. What is the ratio of the Primary completion rate (% of total enrollments) of Benin in 1989 to that in 1990?
Your answer should be very brief. 1.46. What is the ratio of the Primary completion rate (% of total enrollments) of Senegal in 1989 to that in 1990?
Provide a short and direct response. 0.98. What is the ratio of the Primary completion rate (% of total enrollments) in Spain in 1989 to that in 1990?
Ensure brevity in your answer.  1.01. What is the ratio of the Primary completion rate (% of total enrollments) in Middle East & North Africa (all income levels) in 1989 to that in 1994?
Provide a short and direct response. 0.89. What is the ratio of the Primary completion rate (% of total enrollments) of Benin in 1989 to that in 1994?
Offer a terse response. 1.02. What is the ratio of the Primary completion rate (% of total enrollments) of Senegal in 1989 to that in 1994?
Provide a succinct answer. 1.04. What is the ratio of the Primary completion rate (% of total enrollments) in Spain in 1989 to that in 1994?
Your answer should be very brief. 0.99. What is the ratio of the Primary completion rate (% of total enrollments) of Middle East & North Africa (all income levels) in 1989 to that in 2004?
Your response must be concise. 0.74. What is the ratio of the Primary completion rate (% of total enrollments) in Benin in 1989 to that in 2004?
Your response must be concise. 0.42. What is the ratio of the Primary completion rate (% of total enrollments) of Senegal in 1989 to that in 2004?
Your answer should be compact. 0.73. What is the ratio of the Primary completion rate (% of total enrollments) of Spain in 1989 to that in 2004?
Your answer should be very brief. 0.98. What is the ratio of the Primary completion rate (% of total enrollments) of Middle East & North Africa (all income levels) in 1990 to that in 1994?
Give a very brief answer. 0.92. What is the ratio of the Primary completion rate (% of total enrollments) of Benin in 1990 to that in 1994?
Offer a very short reply. 0.7. What is the ratio of the Primary completion rate (% of total enrollments) of Senegal in 1990 to that in 1994?
Keep it short and to the point. 1.06. What is the ratio of the Primary completion rate (% of total enrollments) in Spain in 1990 to that in 1994?
Offer a very short reply. 0.98. What is the ratio of the Primary completion rate (% of total enrollments) of Middle East & North Africa (all income levels) in 1990 to that in 2004?
Offer a terse response. 0.77. What is the ratio of the Primary completion rate (% of total enrollments) of Benin in 1990 to that in 2004?
Offer a terse response. 0.29. What is the ratio of the Primary completion rate (% of total enrollments) in Senegal in 1990 to that in 2004?
Offer a terse response. 0.74. What is the ratio of the Primary completion rate (% of total enrollments) of Spain in 1990 to that in 2004?
Your answer should be very brief. 0.97. What is the ratio of the Primary completion rate (% of total enrollments) in Middle East & North Africa (all income levels) in 1994 to that in 2004?
Your answer should be very brief. 0.83. What is the ratio of the Primary completion rate (% of total enrollments) in Benin in 1994 to that in 2004?
Give a very brief answer. 0.41. What is the ratio of the Primary completion rate (% of total enrollments) in Senegal in 1994 to that in 2004?
Ensure brevity in your answer.  0.7. What is the ratio of the Primary completion rate (% of total enrollments) of Spain in 1994 to that in 2004?
Offer a terse response. 0.99. What is the difference between the highest and the second highest Primary completion rate (% of total enrollments) of Middle East & North Africa (all income levels)?
Make the answer very short. 15.11. What is the difference between the highest and the second highest Primary completion rate (% of total enrollments) of Benin?
Make the answer very short. 21.14. What is the difference between the highest and the second highest Primary completion rate (% of total enrollments) in Senegal?
Your answer should be compact. 11.35. What is the difference between the highest and the second highest Primary completion rate (% of total enrollments) in Spain?
Ensure brevity in your answer.  0.99. What is the difference between the highest and the lowest Primary completion rate (% of total enrollments) of Middle East & North Africa (all income levels)?
Make the answer very short. 26.1. What is the difference between the highest and the lowest Primary completion rate (% of total enrollments) of Benin?
Your response must be concise. 27.87. What is the difference between the highest and the lowest Primary completion rate (% of total enrollments) in Senegal?
Give a very brief answer. 16.21. What is the difference between the highest and the lowest Primary completion rate (% of total enrollments) of Spain?
Provide a short and direct response. 4.95. 